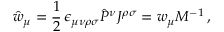Convert formula to latex. <formula><loc_0><loc_0><loc_500><loc_500>\hat { w } _ { \mu } = \frac { 1 } { 2 } \, \epsilon _ { \mu \nu \rho \sigma } \hat { P } ^ { \nu } J ^ { \rho \sigma } = w _ { \mu } M ^ { - 1 } \, ,</formula> 